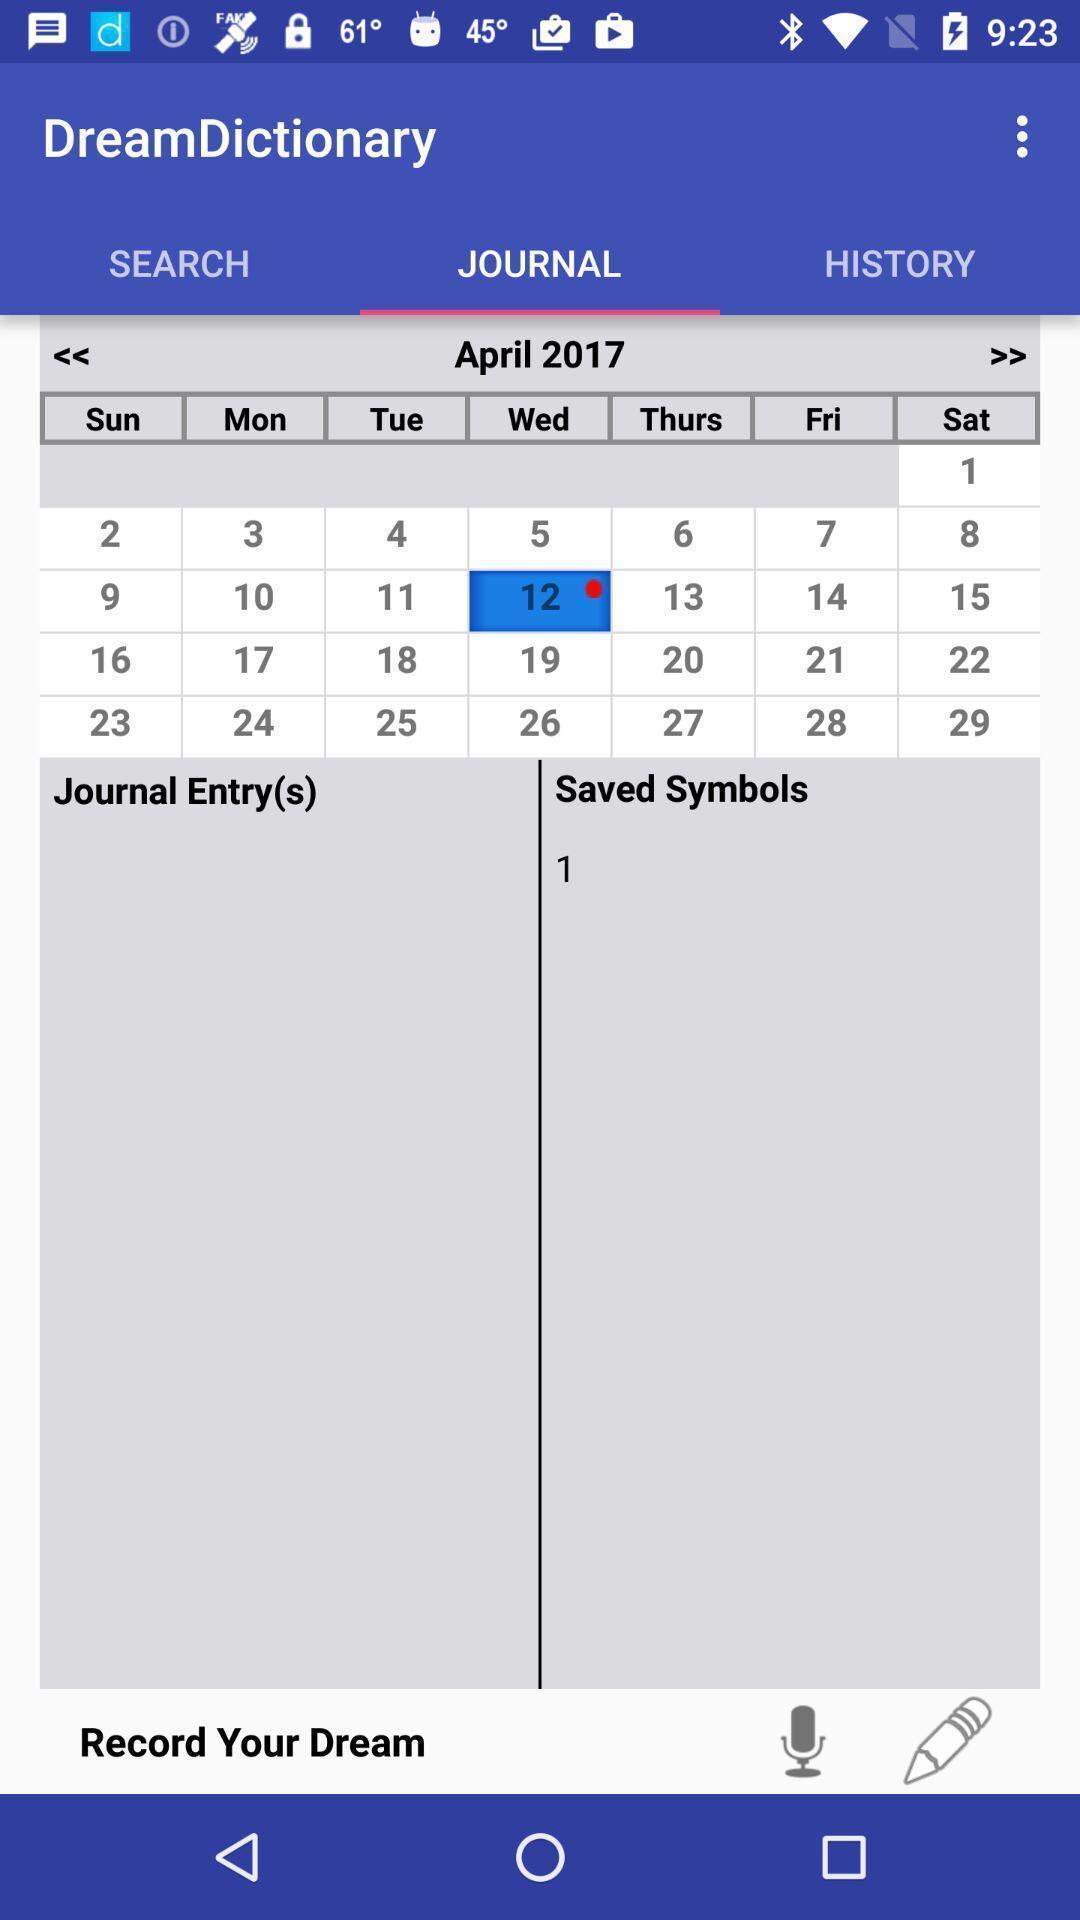Describe the visual elements of this screenshot. Screen displaying contents of a calendar. 